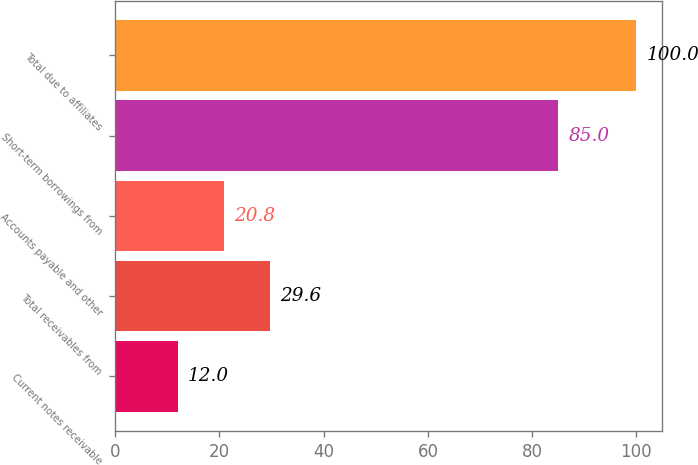Convert chart. <chart><loc_0><loc_0><loc_500><loc_500><bar_chart><fcel>Current notes receivable<fcel>Total receivables from<fcel>Accounts payable and other<fcel>Short-term borrowings from<fcel>Total due to affiliates<nl><fcel>12<fcel>29.6<fcel>20.8<fcel>85<fcel>100<nl></chart> 